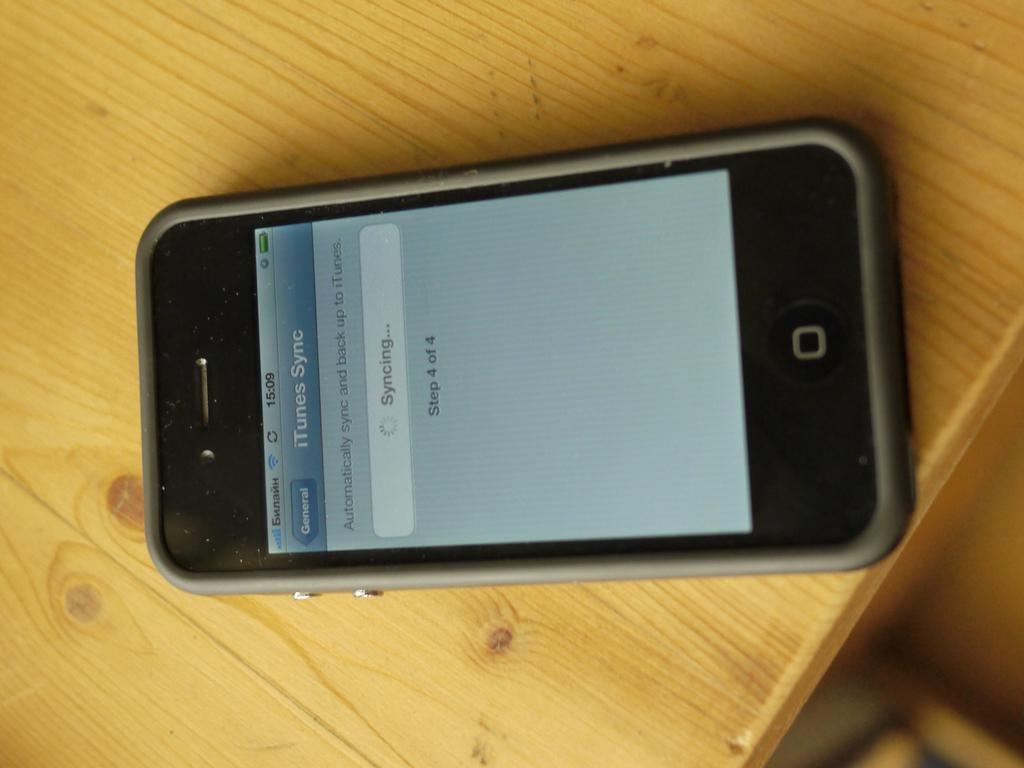<image>
Describe the image concisely. Older iphone that is syncing with itunes on a table 